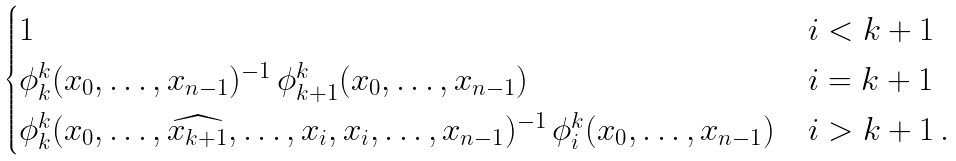<formula> <loc_0><loc_0><loc_500><loc_500>\begin{cases} 1 & i < k + 1 \\ \phi ^ { k } _ { k } ( x _ { 0 } , \dots , x _ { n - 1 } ) ^ { - 1 } \, \phi ^ { k } _ { k + 1 } ( x _ { 0 } , \dots , x _ { n - 1 } ) & i = k + 1 \\ \phi ^ { k } _ { k } ( x _ { 0 } , \dots , \widehat { x _ { k + 1 } } , \dots , x _ { i } , x _ { i } , \dots , x _ { n - 1 } ) ^ { - 1 } \, \phi ^ { k } _ { i } ( x _ { 0 } , \dots , x _ { n - 1 } ) & i > k + 1 \, . \end{cases}</formula> 